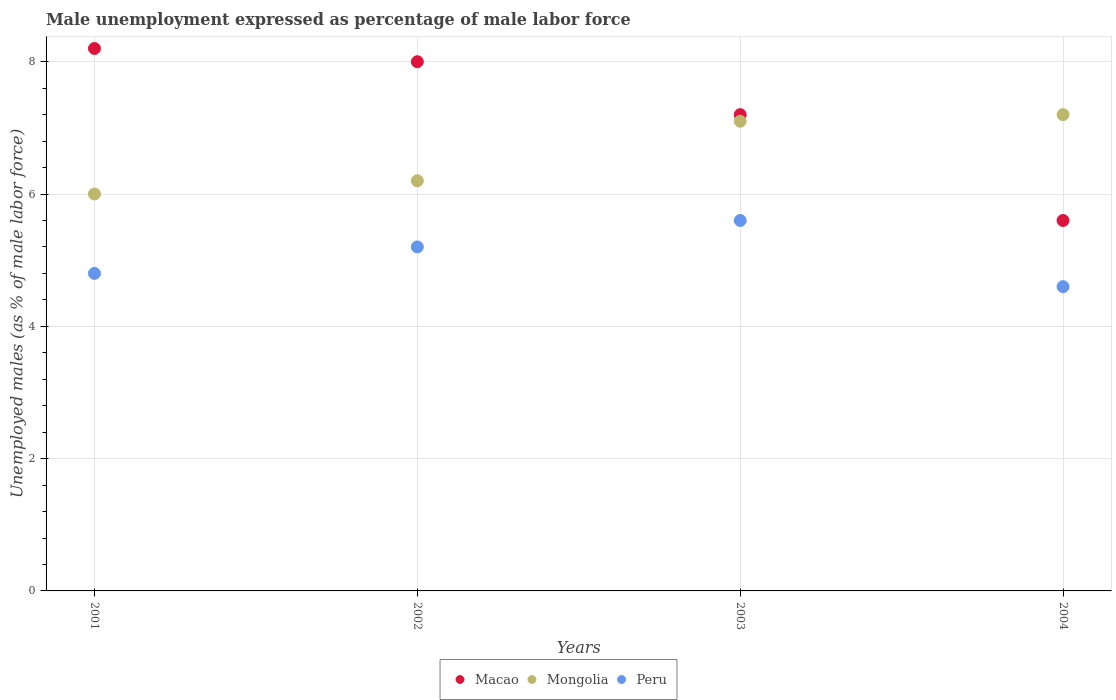How many different coloured dotlines are there?
Keep it short and to the point. 3. What is the unemployment in males in in Mongolia in 2003?
Offer a terse response. 7.1. Across all years, what is the maximum unemployment in males in in Macao?
Make the answer very short. 8.2. Across all years, what is the minimum unemployment in males in in Macao?
Offer a very short reply. 5.6. In which year was the unemployment in males in in Peru maximum?
Provide a succinct answer. 2003. What is the total unemployment in males in in Peru in the graph?
Give a very brief answer. 20.2. What is the difference between the unemployment in males in in Peru in 2001 and that in 2004?
Provide a succinct answer. 0.2. What is the difference between the unemployment in males in in Macao in 2002 and the unemployment in males in in Peru in 2001?
Give a very brief answer. 3.2. What is the average unemployment in males in in Macao per year?
Offer a terse response. 7.25. In the year 2001, what is the difference between the unemployment in males in in Mongolia and unemployment in males in in Peru?
Give a very brief answer. 1.2. In how many years, is the unemployment in males in in Mongolia greater than 0.8 %?
Offer a very short reply. 4. What is the ratio of the unemployment in males in in Mongolia in 2001 to that in 2003?
Provide a succinct answer. 0.85. Is the unemployment in males in in Macao in 2002 less than that in 2003?
Offer a very short reply. No. Is the difference between the unemployment in males in in Mongolia in 2001 and 2004 greater than the difference between the unemployment in males in in Peru in 2001 and 2004?
Ensure brevity in your answer.  No. What is the difference between the highest and the second highest unemployment in males in in Macao?
Ensure brevity in your answer.  0.2. What is the difference between the highest and the lowest unemployment in males in in Peru?
Provide a short and direct response. 1. In how many years, is the unemployment in males in in Mongolia greater than the average unemployment in males in in Mongolia taken over all years?
Provide a succinct answer. 2. Does the unemployment in males in in Macao monotonically increase over the years?
Provide a short and direct response. No. Is the unemployment in males in in Mongolia strictly less than the unemployment in males in in Macao over the years?
Ensure brevity in your answer.  No. How many dotlines are there?
Offer a terse response. 3. Where does the legend appear in the graph?
Offer a terse response. Bottom center. What is the title of the graph?
Give a very brief answer. Male unemployment expressed as percentage of male labor force. Does "New Caledonia" appear as one of the legend labels in the graph?
Offer a terse response. No. What is the label or title of the Y-axis?
Your answer should be very brief. Unemployed males (as % of male labor force). What is the Unemployed males (as % of male labor force) of Macao in 2001?
Offer a terse response. 8.2. What is the Unemployed males (as % of male labor force) of Peru in 2001?
Your answer should be compact. 4.8. What is the Unemployed males (as % of male labor force) of Macao in 2002?
Your response must be concise. 8. What is the Unemployed males (as % of male labor force) of Mongolia in 2002?
Your answer should be very brief. 6.2. What is the Unemployed males (as % of male labor force) of Peru in 2002?
Provide a short and direct response. 5.2. What is the Unemployed males (as % of male labor force) in Macao in 2003?
Your answer should be compact. 7.2. What is the Unemployed males (as % of male labor force) in Mongolia in 2003?
Ensure brevity in your answer.  7.1. What is the Unemployed males (as % of male labor force) of Peru in 2003?
Your response must be concise. 5.6. What is the Unemployed males (as % of male labor force) of Macao in 2004?
Your answer should be compact. 5.6. What is the Unemployed males (as % of male labor force) of Mongolia in 2004?
Ensure brevity in your answer.  7.2. What is the Unemployed males (as % of male labor force) of Peru in 2004?
Provide a succinct answer. 4.6. Across all years, what is the maximum Unemployed males (as % of male labor force) of Macao?
Keep it short and to the point. 8.2. Across all years, what is the maximum Unemployed males (as % of male labor force) in Mongolia?
Give a very brief answer. 7.2. Across all years, what is the maximum Unemployed males (as % of male labor force) in Peru?
Your response must be concise. 5.6. Across all years, what is the minimum Unemployed males (as % of male labor force) in Macao?
Offer a terse response. 5.6. Across all years, what is the minimum Unemployed males (as % of male labor force) of Peru?
Your response must be concise. 4.6. What is the total Unemployed males (as % of male labor force) of Mongolia in the graph?
Your answer should be compact. 26.5. What is the total Unemployed males (as % of male labor force) in Peru in the graph?
Offer a terse response. 20.2. What is the difference between the Unemployed males (as % of male labor force) of Macao in 2001 and that in 2002?
Offer a terse response. 0.2. What is the difference between the Unemployed males (as % of male labor force) in Mongolia in 2001 and that in 2002?
Offer a terse response. -0.2. What is the difference between the Unemployed males (as % of male labor force) of Peru in 2001 and that in 2002?
Your answer should be very brief. -0.4. What is the difference between the Unemployed males (as % of male labor force) in Peru in 2001 and that in 2003?
Your answer should be compact. -0.8. What is the difference between the Unemployed males (as % of male labor force) of Macao in 2001 and that in 2004?
Offer a terse response. 2.6. What is the difference between the Unemployed males (as % of male labor force) in Mongolia in 2001 and that in 2004?
Offer a terse response. -1.2. What is the difference between the Unemployed males (as % of male labor force) in Macao in 2002 and that in 2003?
Your response must be concise. 0.8. What is the difference between the Unemployed males (as % of male labor force) in Mongolia in 2002 and that in 2003?
Give a very brief answer. -0.9. What is the difference between the Unemployed males (as % of male labor force) of Macao in 2002 and that in 2004?
Provide a succinct answer. 2.4. What is the difference between the Unemployed males (as % of male labor force) in Mongolia in 2002 and that in 2004?
Make the answer very short. -1. What is the difference between the Unemployed males (as % of male labor force) of Peru in 2002 and that in 2004?
Keep it short and to the point. 0.6. What is the difference between the Unemployed males (as % of male labor force) in Macao in 2003 and that in 2004?
Keep it short and to the point. 1.6. What is the difference between the Unemployed males (as % of male labor force) in Peru in 2003 and that in 2004?
Provide a short and direct response. 1. What is the difference between the Unemployed males (as % of male labor force) in Macao in 2001 and the Unemployed males (as % of male labor force) in Mongolia in 2002?
Keep it short and to the point. 2. What is the difference between the Unemployed males (as % of male labor force) in Macao in 2001 and the Unemployed males (as % of male labor force) in Peru in 2002?
Offer a very short reply. 3. What is the difference between the Unemployed males (as % of male labor force) of Mongolia in 2001 and the Unemployed males (as % of male labor force) of Peru in 2002?
Make the answer very short. 0.8. What is the difference between the Unemployed males (as % of male labor force) of Macao in 2001 and the Unemployed males (as % of male labor force) of Mongolia in 2003?
Give a very brief answer. 1.1. What is the difference between the Unemployed males (as % of male labor force) in Macao in 2001 and the Unemployed males (as % of male labor force) in Peru in 2003?
Offer a very short reply. 2.6. What is the difference between the Unemployed males (as % of male labor force) of Mongolia in 2001 and the Unemployed males (as % of male labor force) of Peru in 2003?
Keep it short and to the point. 0.4. What is the difference between the Unemployed males (as % of male labor force) of Macao in 2001 and the Unemployed males (as % of male labor force) of Mongolia in 2004?
Your response must be concise. 1. What is the difference between the Unemployed males (as % of male labor force) of Macao in 2001 and the Unemployed males (as % of male labor force) of Peru in 2004?
Provide a short and direct response. 3.6. What is the difference between the Unemployed males (as % of male labor force) of Mongolia in 2002 and the Unemployed males (as % of male labor force) of Peru in 2003?
Give a very brief answer. 0.6. What is the difference between the Unemployed males (as % of male labor force) of Macao in 2002 and the Unemployed males (as % of male labor force) of Mongolia in 2004?
Give a very brief answer. 0.8. What is the difference between the Unemployed males (as % of male labor force) of Macao in 2002 and the Unemployed males (as % of male labor force) of Peru in 2004?
Give a very brief answer. 3.4. What is the difference between the Unemployed males (as % of male labor force) in Mongolia in 2002 and the Unemployed males (as % of male labor force) in Peru in 2004?
Your answer should be compact. 1.6. What is the difference between the Unemployed males (as % of male labor force) of Macao in 2003 and the Unemployed males (as % of male labor force) of Mongolia in 2004?
Your answer should be very brief. 0. What is the average Unemployed males (as % of male labor force) of Macao per year?
Provide a succinct answer. 7.25. What is the average Unemployed males (as % of male labor force) in Mongolia per year?
Offer a terse response. 6.62. What is the average Unemployed males (as % of male labor force) of Peru per year?
Provide a succinct answer. 5.05. In the year 2001, what is the difference between the Unemployed males (as % of male labor force) of Macao and Unemployed males (as % of male labor force) of Peru?
Provide a succinct answer. 3.4. In the year 2002, what is the difference between the Unemployed males (as % of male labor force) in Macao and Unemployed males (as % of male labor force) in Peru?
Your response must be concise. 2.8. In the year 2003, what is the difference between the Unemployed males (as % of male labor force) in Macao and Unemployed males (as % of male labor force) in Peru?
Offer a terse response. 1.6. In the year 2004, what is the difference between the Unemployed males (as % of male labor force) of Macao and Unemployed males (as % of male labor force) of Mongolia?
Provide a short and direct response. -1.6. In the year 2004, what is the difference between the Unemployed males (as % of male labor force) in Macao and Unemployed males (as % of male labor force) in Peru?
Provide a short and direct response. 1. What is the ratio of the Unemployed males (as % of male labor force) of Macao in 2001 to that in 2002?
Provide a succinct answer. 1.02. What is the ratio of the Unemployed males (as % of male labor force) of Macao in 2001 to that in 2003?
Keep it short and to the point. 1.14. What is the ratio of the Unemployed males (as % of male labor force) of Mongolia in 2001 to that in 2003?
Offer a very short reply. 0.85. What is the ratio of the Unemployed males (as % of male labor force) of Macao in 2001 to that in 2004?
Give a very brief answer. 1.46. What is the ratio of the Unemployed males (as % of male labor force) in Peru in 2001 to that in 2004?
Make the answer very short. 1.04. What is the ratio of the Unemployed males (as % of male labor force) of Macao in 2002 to that in 2003?
Provide a short and direct response. 1.11. What is the ratio of the Unemployed males (as % of male labor force) in Mongolia in 2002 to that in 2003?
Make the answer very short. 0.87. What is the ratio of the Unemployed males (as % of male labor force) of Peru in 2002 to that in 2003?
Provide a succinct answer. 0.93. What is the ratio of the Unemployed males (as % of male labor force) of Macao in 2002 to that in 2004?
Make the answer very short. 1.43. What is the ratio of the Unemployed males (as % of male labor force) of Mongolia in 2002 to that in 2004?
Offer a terse response. 0.86. What is the ratio of the Unemployed males (as % of male labor force) of Peru in 2002 to that in 2004?
Your response must be concise. 1.13. What is the ratio of the Unemployed males (as % of male labor force) of Mongolia in 2003 to that in 2004?
Make the answer very short. 0.99. What is the ratio of the Unemployed males (as % of male labor force) of Peru in 2003 to that in 2004?
Your response must be concise. 1.22. What is the difference between the highest and the second highest Unemployed males (as % of male labor force) in Peru?
Your response must be concise. 0.4. What is the difference between the highest and the lowest Unemployed males (as % of male labor force) of Mongolia?
Provide a succinct answer. 1.2. 